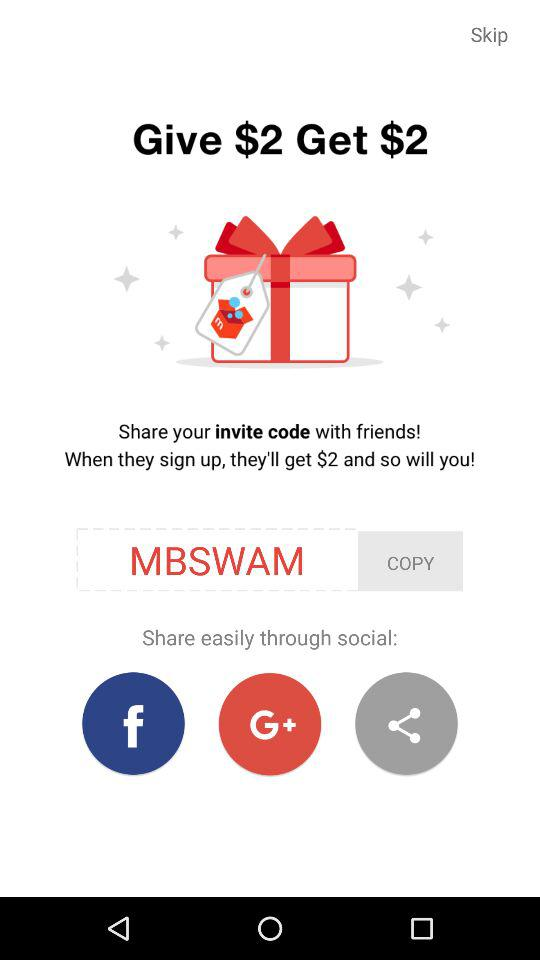How much money will I get if I sign up with the invite code?
Answer the question using a single word or phrase. $2 